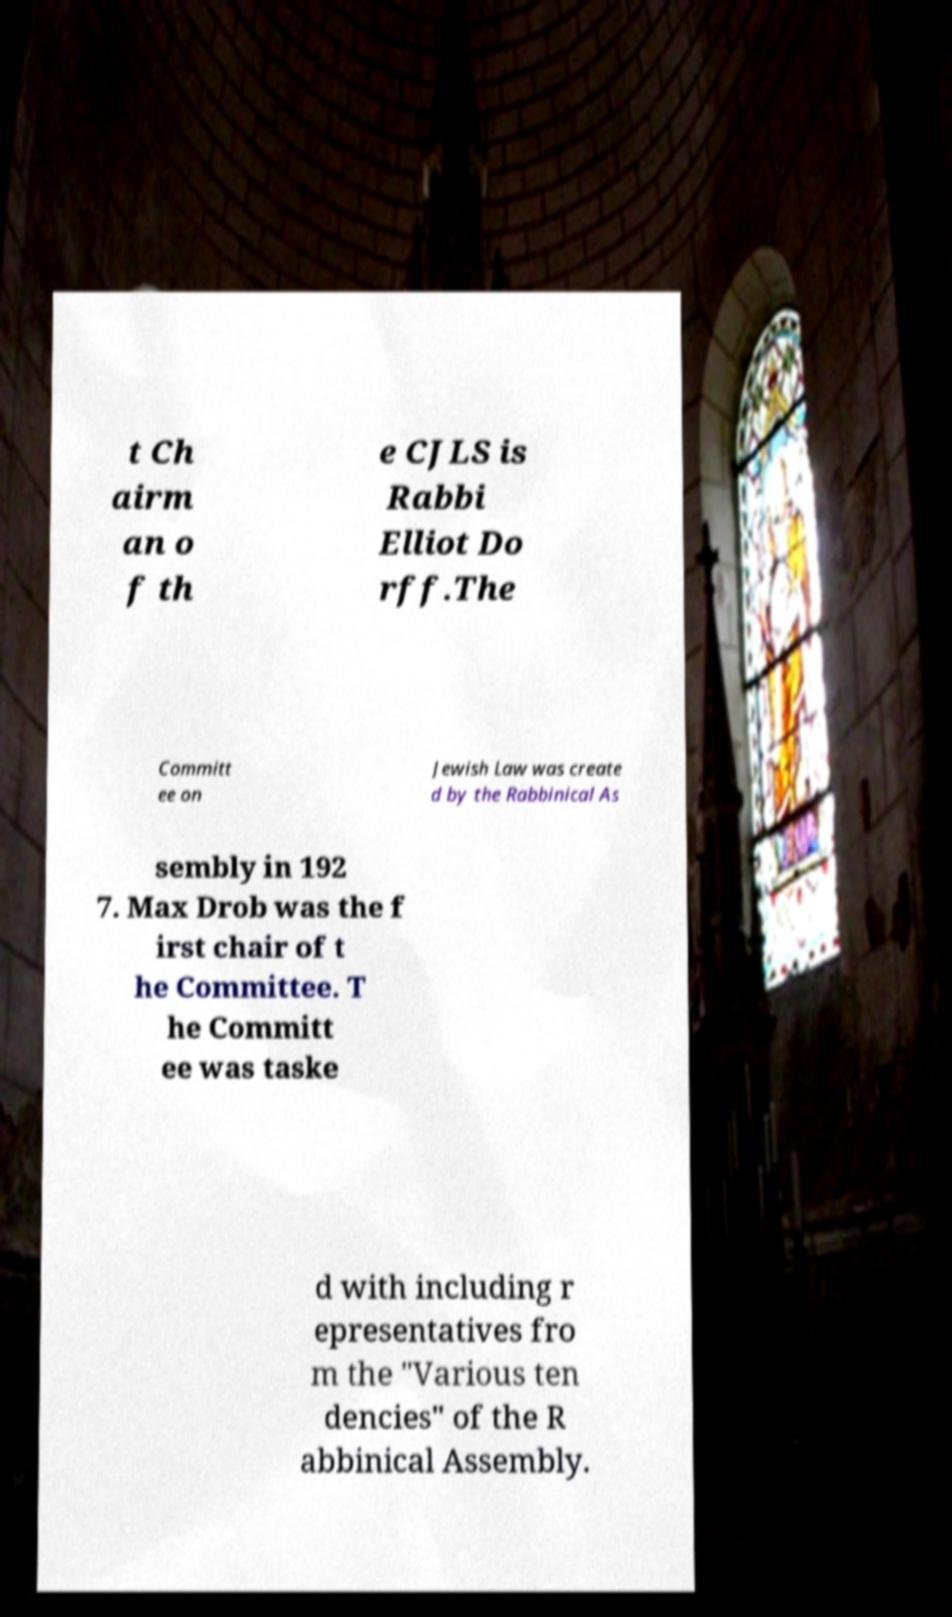Could you assist in decoding the text presented in this image and type it out clearly? t Ch airm an o f th e CJLS is Rabbi Elliot Do rff.The Committ ee on Jewish Law was create d by the Rabbinical As sembly in 192 7. Max Drob was the f irst chair of t he Committee. T he Committ ee was taske d with including r epresentatives fro m the "Various ten dencies" of the R abbinical Assembly. 